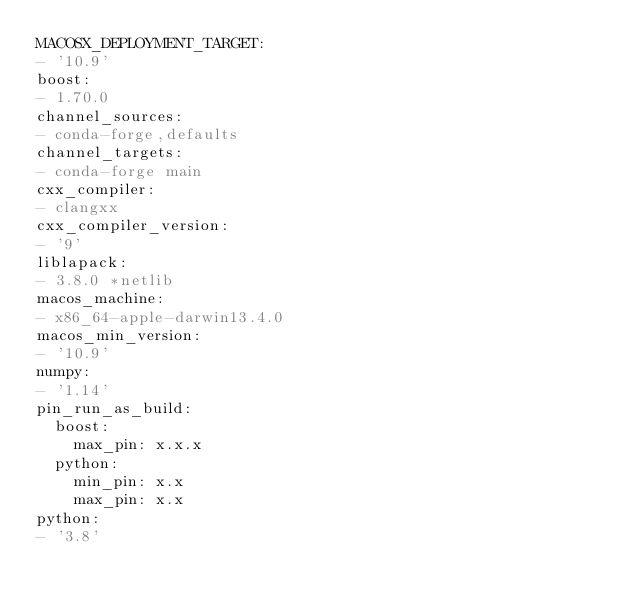Convert code to text. <code><loc_0><loc_0><loc_500><loc_500><_YAML_>MACOSX_DEPLOYMENT_TARGET:
- '10.9'
boost:
- 1.70.0
channel_sources:
- conda-forge,defaults
channel_targets:
- conda-forge main
cxx_compiler:
- clangxx
cxx_compiler_version:
- '9'
liblapack:
- 3.8.0 *netlib
macos_machine:
- x86_64-apple-darwin13.4.0
macos_min_version:
- '10.9'
numpy:
- '1.14'
pin_run_as_build:
  boost:
    max_pin: x.x.x
  python:
    min_pin: x.x
    max_pin: x.x
python:
- '3.8'
</code> 